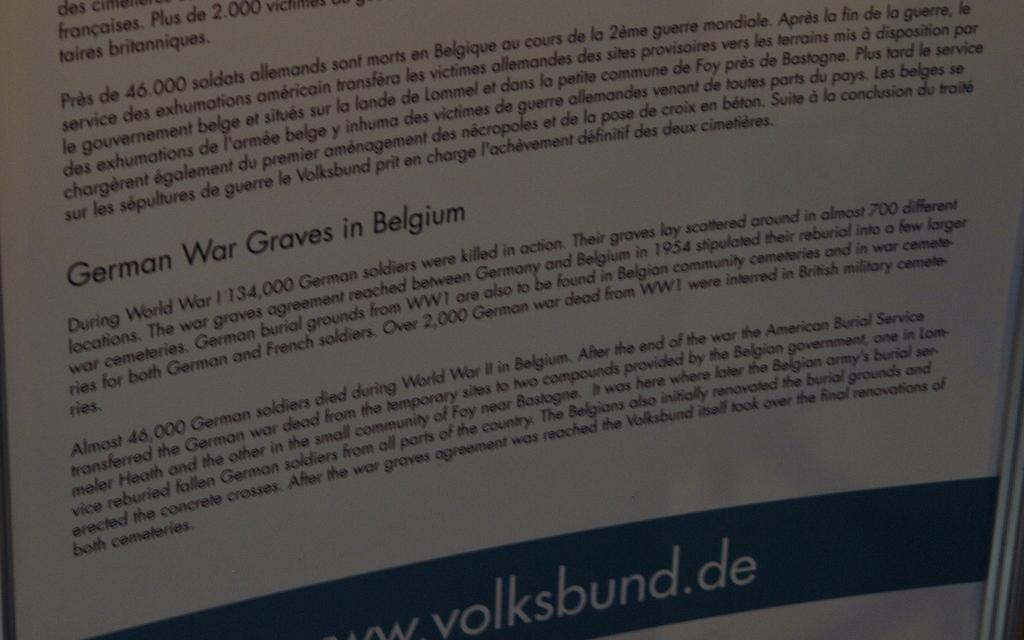<image>
Share a concise interpretation of the image provided. Page from a book with a paragraph titled "German War Graves in Belgium". 